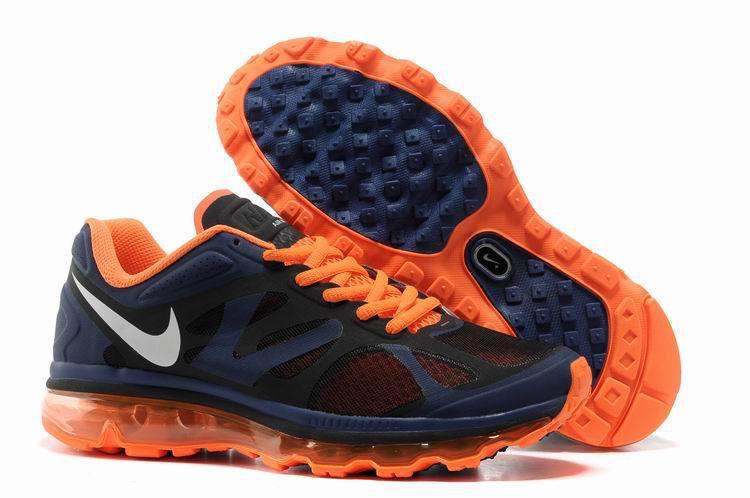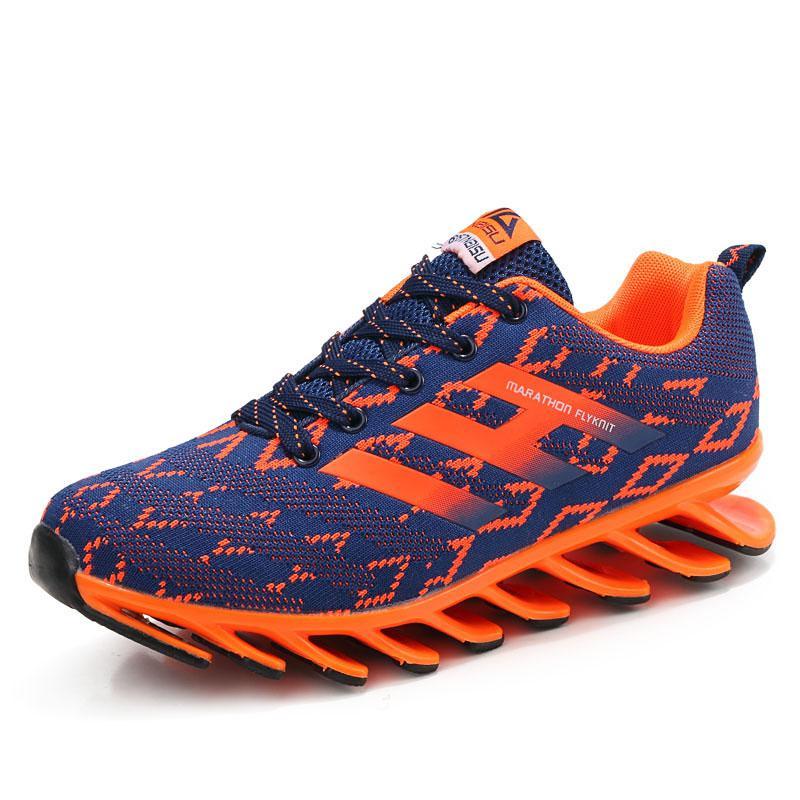The first image is the image on the left, the second image is the image on the right. Considering the images on both sides, is "There is exactly one shoe in the image on the right." valid? Answer yes or no. Yes. The first image is the image on the left, the second image is the image on the right. Evaluate the accuracy of this statement regarding the images: "One image features an orange shoe with a gray sole.". Is it true? Answer yes or no. No. 